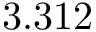<formula> <loc_0><loc_0><loc_500><loc_500>3 . 3 1 2</formula> 